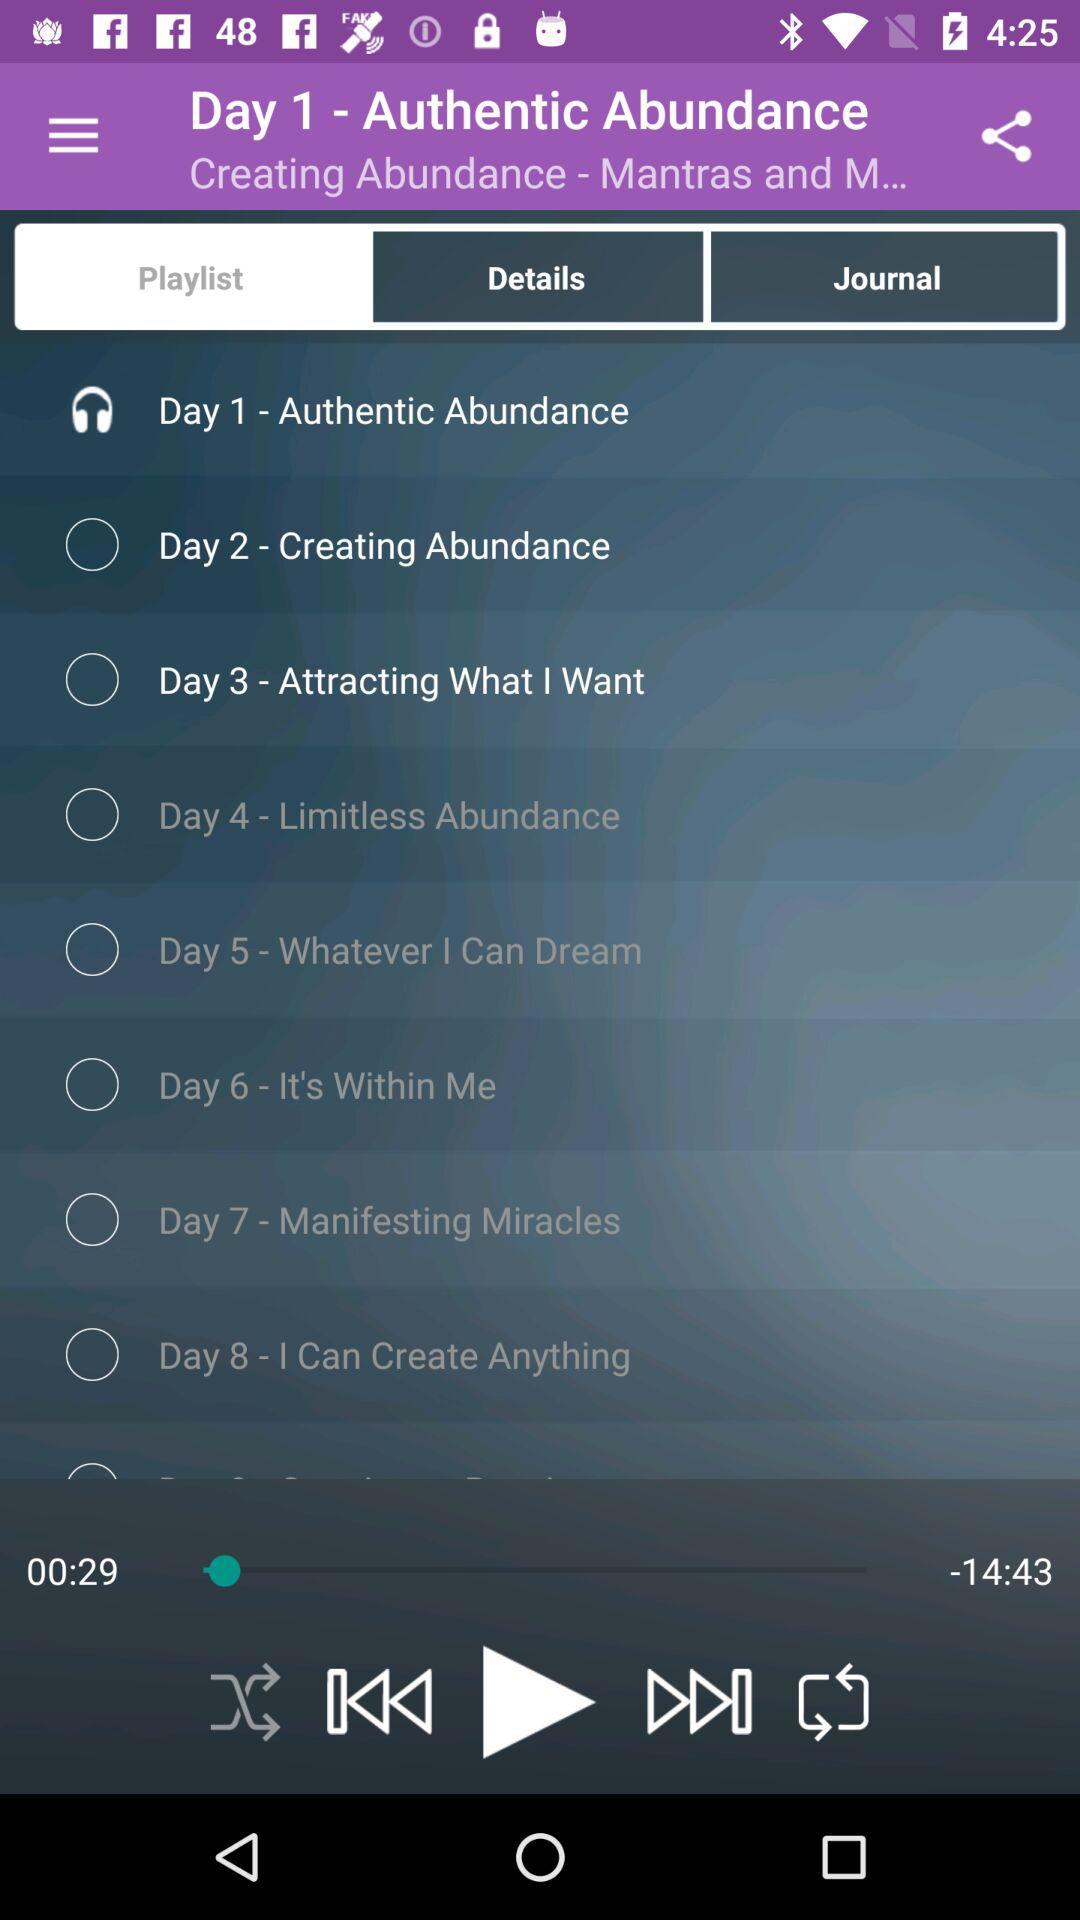What track will be played on day seven? The track that will be played on day seven is "Manifesting Miracles". 